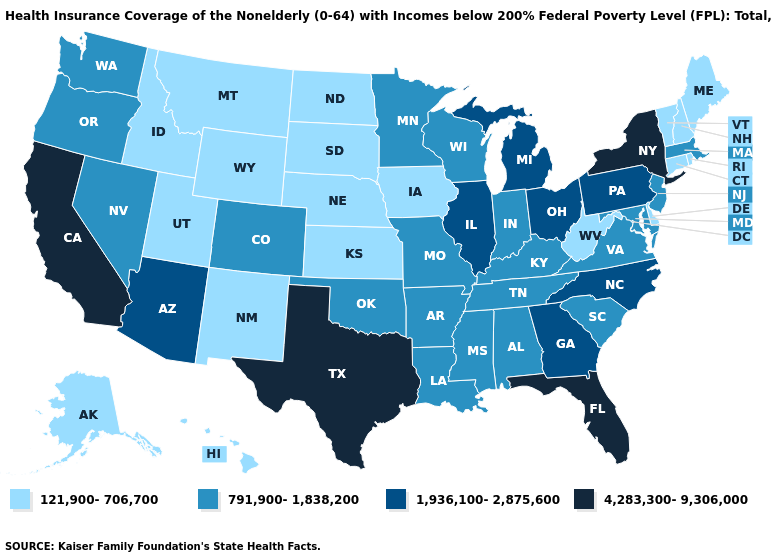Name the states that have a value in the range 121,900-706,700?
Quick response, please. Alaska, Connecticut, Delaware, Hawaii, Idaho, Iowa, Kansas, Maine, Montana, Nebraska, New Hampshire, New Mexico, North Dakota, Rhode Island, South Dakota, Utah, Vermont, West Virginia, Wyoming. Is the legend a continuous bar?
Concise answer only. No. Name the states that have a value in the range 4,283,300-9,306,000?
Give a very brief answer. California, Florida, New York, Texas. Name the states that have a value in the range 4,283,300-9,306,000?
Answer briefly. California, Florida, New York, Texas. Which states have the lowest value in the West?
Short answer required. Alaska, Hawaii, Idaho, Montana, New Mexico, Utah, Wyoming. Among the states that border Nebraska , which have the highest value?
Write a very short answer. Colorado, Missouri. Does Alaska have the lowest value in the West?
Short answer required. Yes. What is the lowest value in the USA?
Be succinct. 121,900-706,700. Which states have the highest value in the USA?
Answer briefly. California, Florida, New York, Texas. What is the value of Rhode Island?
Be succinct. 121,900-706,700. Does Minnesota have the lowest value in the USA?
Answer briefly. No. Among the states that border Ohio , does West Virginia have the lowest value?
Quick response, please. Yes. Name the states that have a value in the range 4,283,300-9,306,000?
Concise answer only. California, Florida, New York, Texas. Name the states that have a value in the range 121,900-706,700?
Concise answer only. Alaska, Connecticut, Delaware, Hawaii, Idaho, Iowa, Kansas, Maine, Montana, Nebraska, New Hampshire, New Mexico, North Dakota, Rhode Island, South Dakota, Utah, Vermont, West Virginia, Wyoming. Does the map have missing data?
Give a very brief answer. No. 